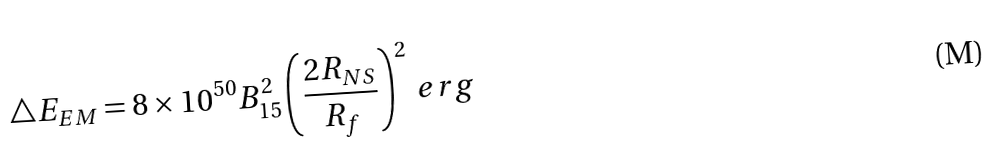Convert formula to latex. <formula><loc_0><loc_0><loc_500><loc_500>\bigtriangleup E _ { E M } = 8 \times 1 0 ^ { 5 0 } B _ { 1 5 } ^ { 2 } \left ( \frac { 2 R _ { N S } } { R _ { f } } \right ) ^ { 2 } \, e r g</formula> 